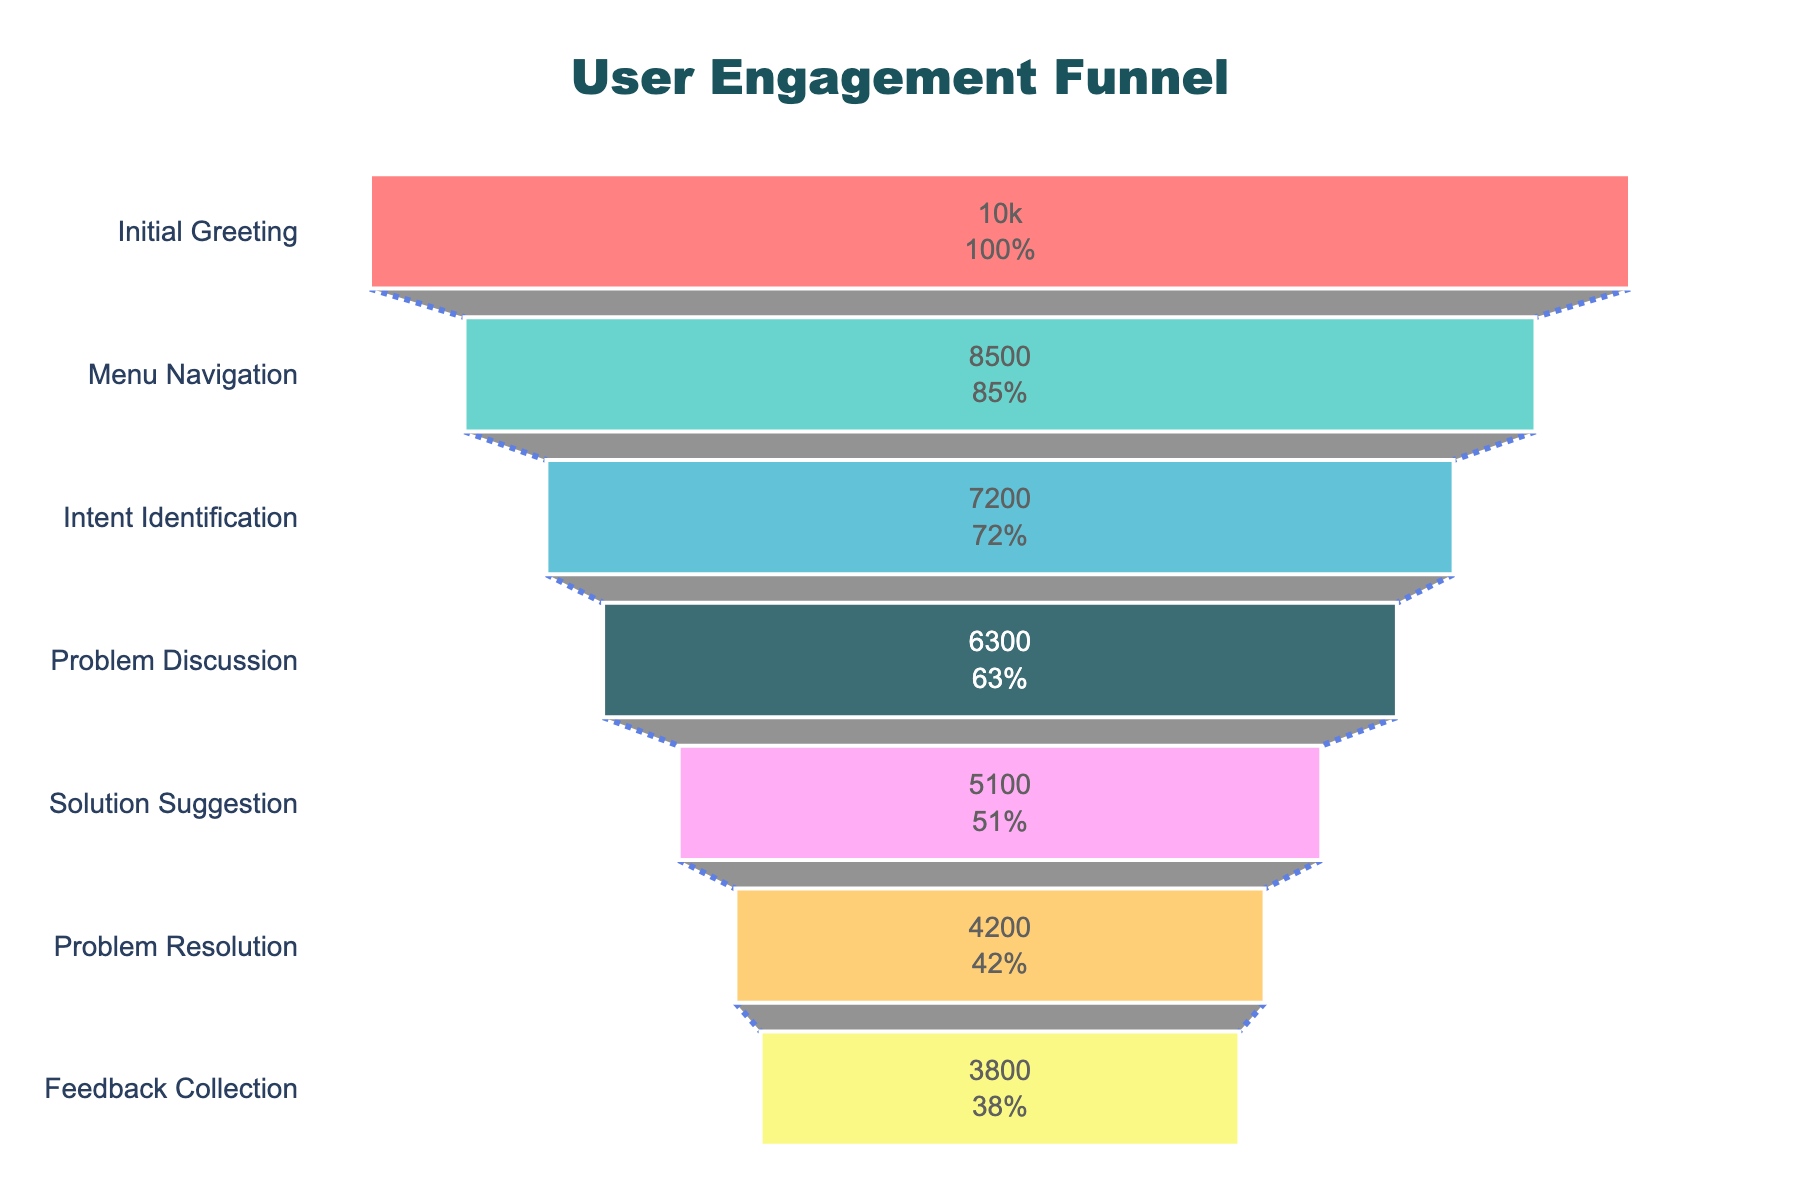What's the total number of users at the beginning of the interaction funnel? The number of users at the "Initial Greeting" stage can be directly identified from the topmost part of the funnel chart. This is the starting point of user engagement.
Answer: 10,000 What percentage of users drop off between the "Initial Greeting" and "Menu Navigation" stages? First, find the number of users at both stages (10,000 for "Initial Greeting" and 8,500 for "Menu Navigation"). Then, calculate the difference (10,000 - 8,500 = 1,500). Finally, compute the percentage: (1,500 / 10,000) * 100%.
Answer: 15% At which stage does the drop in user engagement exceed 1,000 users for the first time? To identify the first stage with a drop exceeding 1,000 users, examine the difference between consecutive stages. The difference between "Menu Navigation" (8,500) and "Intent Identification" (7,200) is 1,300 users, which is the first drop exceeding 1,000 users.
Answer: Intent Identification How many users progress from the "Problem Discussion" stage to the "Solution Suggestion" stage? Look at the values for both stages: "Problem Discussion" has 6,300 users and "Solution Suggestion" has 5,100 users. The number of users progressing is thus 5,100.
Answer: 5,100 What's the difference in user count between the "Problem Resolution" and "Feedback Collection" stages? Check the chart for the user counts at both stages (4,200 at "Problem Resolution" and 3,800 at "Feedback Collection"). The difference is 4,200 - 3,800 = 400 users.
Answer: 400 Which stage in the funnel has the highest drop-off rate in terms of absolute number of users? To find the stage with the highest drop-off, calculate the differences between consecutive stages. The highest absolute drop-off is between "Solution Suggestion" (5,100) and "Problem Resolution" (4,200), which is 900 users.
Answer: Solution Suggestion to Problem Resolution By what percentage does user engagement reduce from "Solution Suggestion" to "Problem Resolution"? Compute the number of users at both stages (5,100 for "Solution Suggestion" and 4,200 for "Problem Resolution"). The drop is 900 users. The percentage reduction is (900 / 5,100) * 100%.
Answer: 17.65% What is the number of stages in the user engagement funnel? Count the distinct stages listed on the y-axis of the funnel chart. There are 7 stages.
Answer: 7 Is there a stage where less than half of the original 10,000 users remain? Check each stage to identify where the user count falls below 5,000. The "Solution Suggestion" stage has 5,100 users and the "Problem Resolution" stage has 4,200 users, indicating less than half remain at "Problem Resolution".
Answer: Problem Resolution 